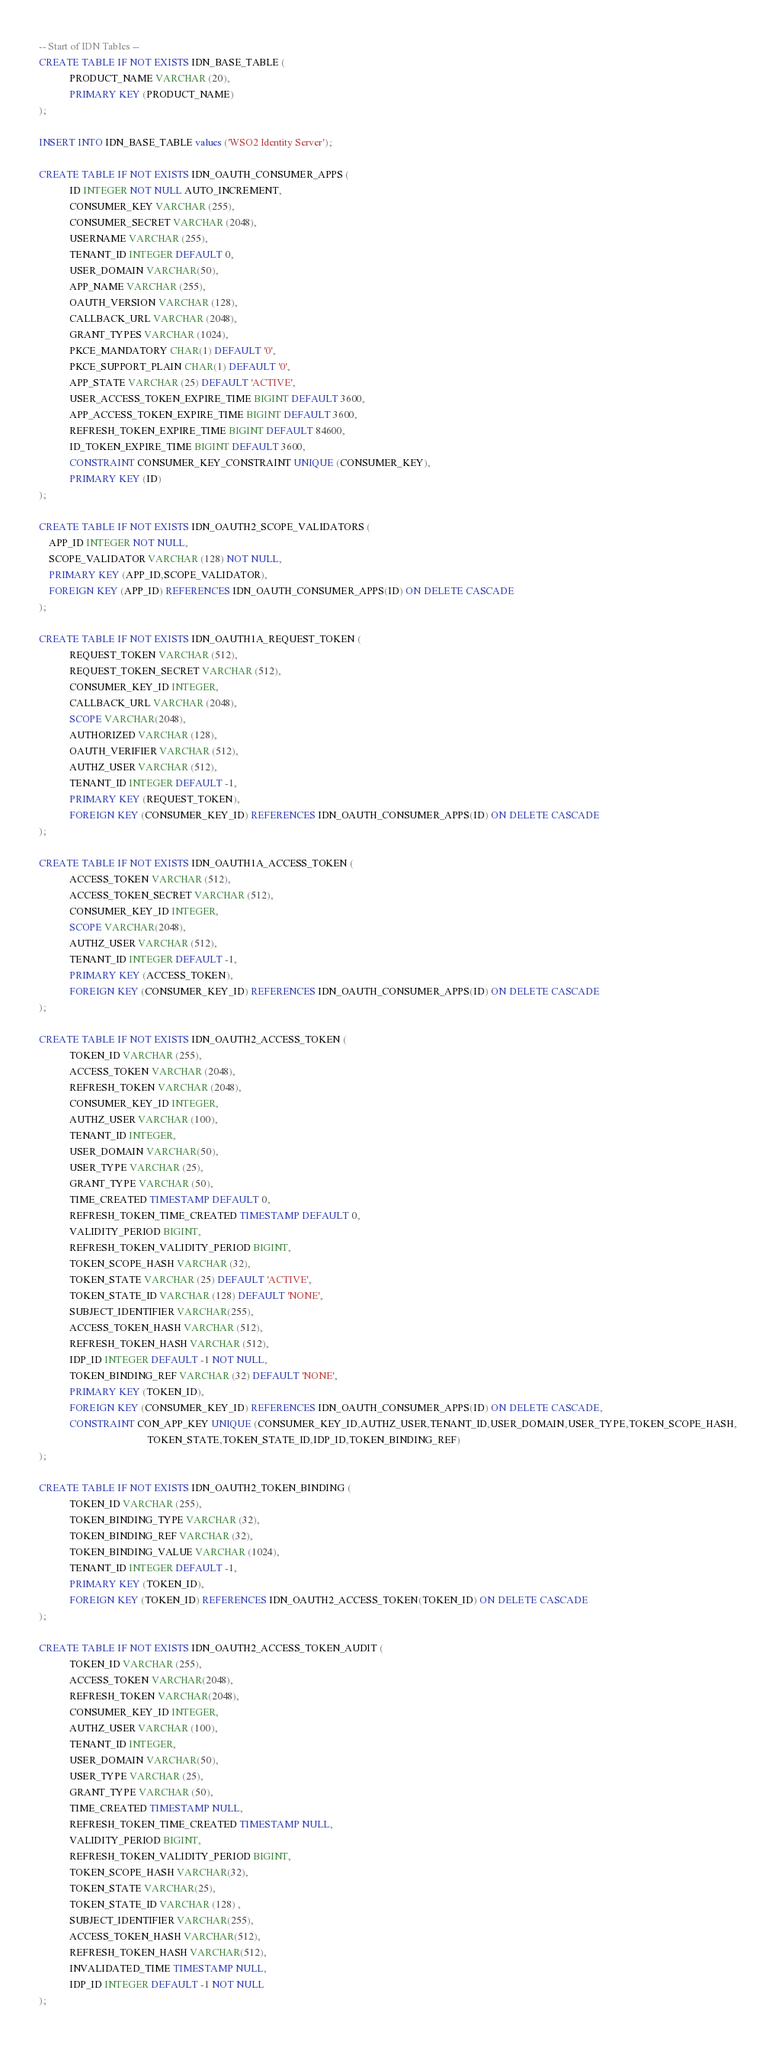<code> <loc_0><loc_0><loc_500><loc_500><_SQL_>-- Start of IDN Tables --
CREATE TABLE IF NOT EXISTS IDN_BASE_TABLE (
            PRODUCT_NAME VARCHAR (20),
            PRIMARY KEY (PRODUCT_NAME)
);

INSERT INTO IDN_BASE_TABLE values ('WSO2 Identity Server');

CREATE TABLE IF NOT EXISTS IDN_OAUTH_CONSUMER_APPS (
            ID INTEGER NOT NULL AUTO_INCREMENT,
            CONSUMER_KEY VARCHAR (255),
            CONSUMER_SECRET VARCHAR (2048),
            USERNAME VARCHAR (255),
            TENANT_ID INTEGER DEFAULT 0,
            USER_DOMAIN VARCHAR(50),
            APP_NAME VARCHAR (255),
            OAUTH_VERSION VARCHAR (128),
            CALLBACK_URL VARCHAR (2048),
            GRANT_TYPES VARCHAR (1024),
            PKCE_MANDATORY CHAR(1) DEFAULT '0',
            PKCE_SUPPORT_PLAIN CHAR(1) DEFAULT '0',
            APP_STATE VARCHAR (25) DEFAULT 'ACTIVE',
            USER_ACCESS_TOKEN_EXPIRE_TIME BIGINT DEFAULT 3600,
            APP_ACCESS_TOKEN_EXPIRE_TIME BIGINT DEFAULT 3600,
            REFRESH_TOKEN_EXPIRE_TIME BIGINT DEFAULT 84600,
            ID_TOKEN_EXPIRE_TIME BIGINT DEFAULT 3600,
            CONSTRAINT CONSUMER_KEY_CONSTRAINT UNIQUE (CONSUMER_KEY),
            PRIMARY KEY (ID)
);

CREATE TABLE IF NOT EXISTS IDN_OAUTH2_SCOPE_VALIDATORS (
	APP_ID INTEGER NOT NULL,
	SCOPE_VALIDATOR VARCHAR (128) NOT NULL,
	PRIMARY KEY (APP_ID,SCOPE_VALIDATOR),
	FOREIGN KEY (APP_ID) REFERENCES IDN_OAUTH_CONSUMER_APPS(ID) ON DELETE CASCADE
);

CREATE TABLE IF NOT EXISTS IDN_OAUTH1A_REQUEST_TOKEN (
            REQUEST_TOKEN VARCHAR (512),
            REQUEST_TOKEN_SECRET VARCHAR (512),
            CONSUMER_KEY_ID INTEGER,
            CALLBACK_URL VARCHAR (2048),
            SCOPE VARCHAR(2048),
            AUTHORIZED VARCHAR (128),
            OAUTH_VERIFIER VARCHAR (512),
            AUTHZ_USER VARCHAR (512),
            TENANT_ID INTEGER DEFAULT -1,
            PRIMARY KEY (REQUEST_TOKEN),
            FOREIGN KEY (CONSUMER_KEY_ID) REFERENCES IDN_OAUTH_CONSUMER_APPS(ID) ON DELETE CASCADE
);

CREATE TABLE IF NOT EXISTS IDN_OAUTH1A_ACCESS_TOKEN (
            ACCESS_TOKEN VARCHAR (512),
            ACCESS_TOKEN_SECRET VARCHAR (512),
            CONSUMER_KEY_ID INTEGER,
            SCOPE VARCHAR(2048),
            AUTHZ_USER VARCHAR (512),
            TENANT_ID INTEGER DEFAULT -1,
            PRIMARY KEY (ACCESS_TOKEN),
            FOREIGN KEY (CONSUMER_KEY_ID) REFERENCES IDN_OAUTH_CONSUMER_APPS(ID) ON DELETE CASCADE
);

CREATE TABLE IF NOT EXISTS IDN_OAUTH2_ACCESS_TOKEN (
            TOKEN_ID VARCHAR (255),
            ACCESS_TOKEN VARCHAR (2048),
            REFRESH_TOKEN VARCHAR (2048),
            CONSUMER_KEY_ID INTEGER,
            AUTHZ_USER VARCHAR (100),
            TENANT_ID INTEGER,
            USER_DOMAIN VARCHAR(50),
            USER_TYPE VARCHAR (25),
            GRANT_TYPE VARCHAR (50),
            TIME_CREATED TIMESTAMP DEFAULT 0,
            REFRESH_TOKEN_TIME_CREATED TIMESTAMP DEFAULT 0,
            VALIDITY_PERIOD BIGINT,
            REFRESH_TOKEN_VALIDITY_PERIOD BIGINT,
            TOKEN_SCOPE_HASH VARCHAR (32),
            TOKEN_STATE VARCHAR (25) DEFAULT 'ACTIVE',
            TOKEN_STATE_ID VARCHAR (128) DEFAULT 'NONE',
            SUBJECT_IDENTIFIER VARCHAR(255),
            ACCESS_TOKEN_HASH VARCHAR (512),
            REFRESH_TOKEN_HASH VARCHAR (512),
            IDP_ID INTEGER DEFAULT -1 NOT NULL,
            TOKEN_BINDING_REF VARCHAR (32) DEFAULT 'NONE',
            PRIMARY KEY (TOKEN_ID),
            FOREIGN KEY (CONSUMER_KEY_ID) REFERENCES IDN_OAUTH_CONSUMER_APPS(ID) ON DELETE CASCADE,
            CONSTRAINT CON_APP_KEY UNIQUE (CONSUMER_KEY_ID,AUTHZ_USER,TENANT_ID,USER_DOMAIN,USER_TYPE,TOKEN_SCOPE_HASH,
                                           TOKEN_STATE,TOKEN_STATE_ID,IDP_ID,TOKEN_BINDING_REF)
);

CREATE TABLE IF NOT EXISTS IDN_OAUTH2_TOKEN_BINDING (
            TOKEN_ID VARCHAR (255),
            TOKEN_BINDING_TYPE VARCHAR (32),
            TOKEN_BINDING_REF VARCHAR (32),
            TOKEN_BINDING_VALUE VARCHAR (1024),
            TENANT_ID INTEGER DEFAULT -1,
            PRIMARY KEY (TOKEN_ID),
            FOREIGN KEY (TOKEN_ID) REFERENCES IDN_OAUTH2_ACCESS_TOKEN(TOKEN_ID) ON DELETE CASCADE
);

CREATE TABLE IF NOT EXISTS IDN_OAUTH2_ACCESS_TOKEN_AUDIT (
            TOKEN_ID VARCHAR (255),
            ACCESS_TOKEN VARCHAR(2048),
            REFRESH_TOKEN VARCHAR(2048),
            CONSUMER_KEY_ID INTEGER,
            AUTHZ_USER VARCHAR (100),
            TENANT_ID INTEGER,
            USER_DOMAIN VARCHAR(50),
            USER_TYPE VARCHAR (25),
            GRANT_TYPE VARCHAR (50),
            TIME_CREATED TIMESTAMP NULL,
            REFRESH_TOKEN_TIME_CREATED TIMESTAMP NULL,
            VALIDITY_PERIOD BIGINT,
            REFRESH_TOKEN_VALIDITY_PERIOD BIGINT,
            TOKEN_SCOPE_HASH VARCHAR(32),
            TOKEN_STATE VARCHAR(25),
            TOKEN_STATE_ID VARCHAR (128) ,
            SUBJECT_IDENTIFIER VARCHAR(255),
            ACCESS_TOKEN_HASH VARCHAR(512),
            REFRESH_TOKEN_HASH VARCHAR(512),
            INVALIDATED_TIME TIMESTAMP NULL,
            IDP_ID INTEGER DEFAULT -1 NOT NULL
);

</code> 